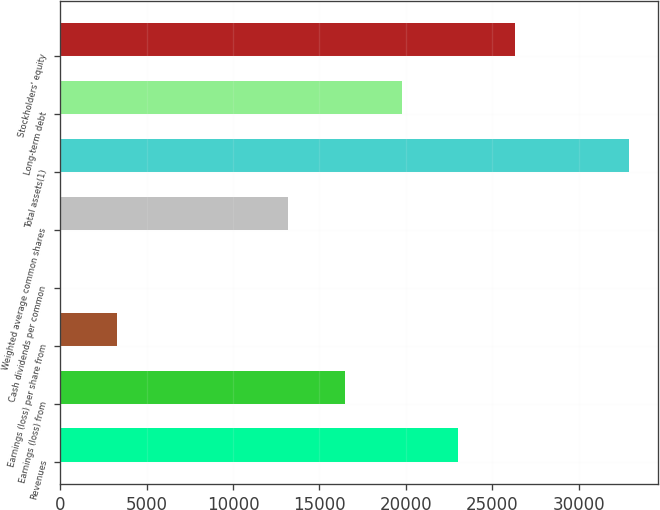<chart> <loc_0><loc_0><loc_500><loc_500><bar_chart><fcel>Revenues<fcel>Earnings (loss) from<fcel>Earnings (loss) per share from<fcel>Cash dividends per common<fcel>Weighted average common shares<fcel>Total assets(1)<fcel>Long-term debt<fcel>Stockholders' equity<nl><fcel>23049.1<fcel>16463.8<fcel>3293.28<fcel>0.64<fcel>13171.2<fcel>32927<fcel>19756.5<fcel>26341.8<nl></chart> 